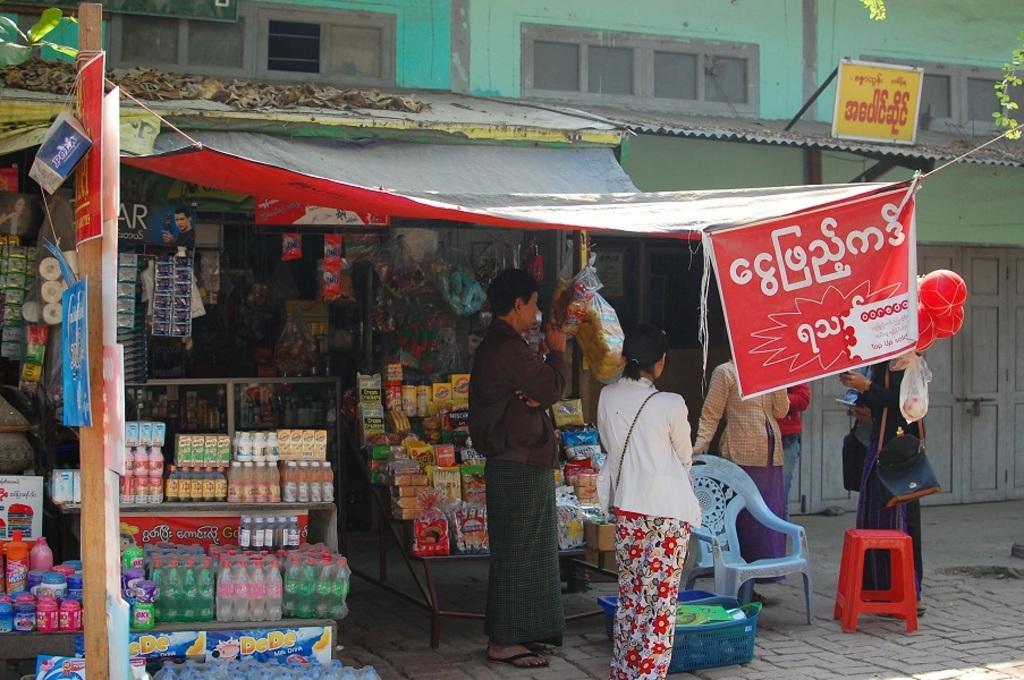Can you describe this image briefly? I can see few people standing. This is the banner, which is hanging. I think this is the shop with few objects and things. This is the chair and stool. This looks like a basket with objects in it. Here is the board. This is the building with windows and doors. 